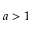<formula> <loc_0><loc_0><loc_500><loc_500>a > 1</formula> 